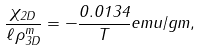<formula> <loc_0><loc_0><loc_500><loc_500>\frac { \chi _ { 2 D } } { \ell \rho _ { 3 D } ^ { m } } = - \frac { 0 . 0 1 3 4 } { T } e m u / g m ,</formula> 